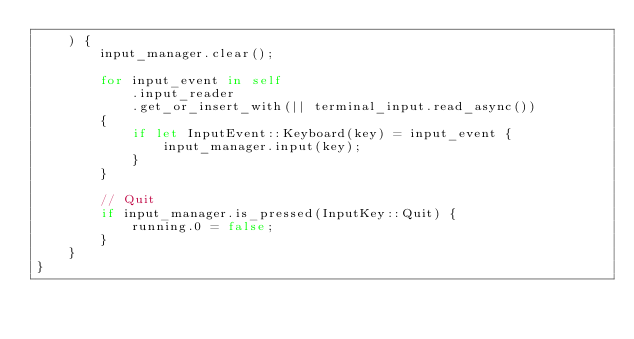<code> <loc_0><loc_0><loc_500><loc_500><_Rust_>    ) {
        input_manager.clear();

        for input_event in self
            .input_reader
            .get_or_insert_with(|| terminal_input.read_async())
        {
            if let InputEvent::Keyboard(key) = input_event {
                input_manager.input(key);
            }
        }

        // Quit
        if input_manager.is_pressed(InputKey::Quit) {
            running.0 = false;
        }
    }
}
</code> 